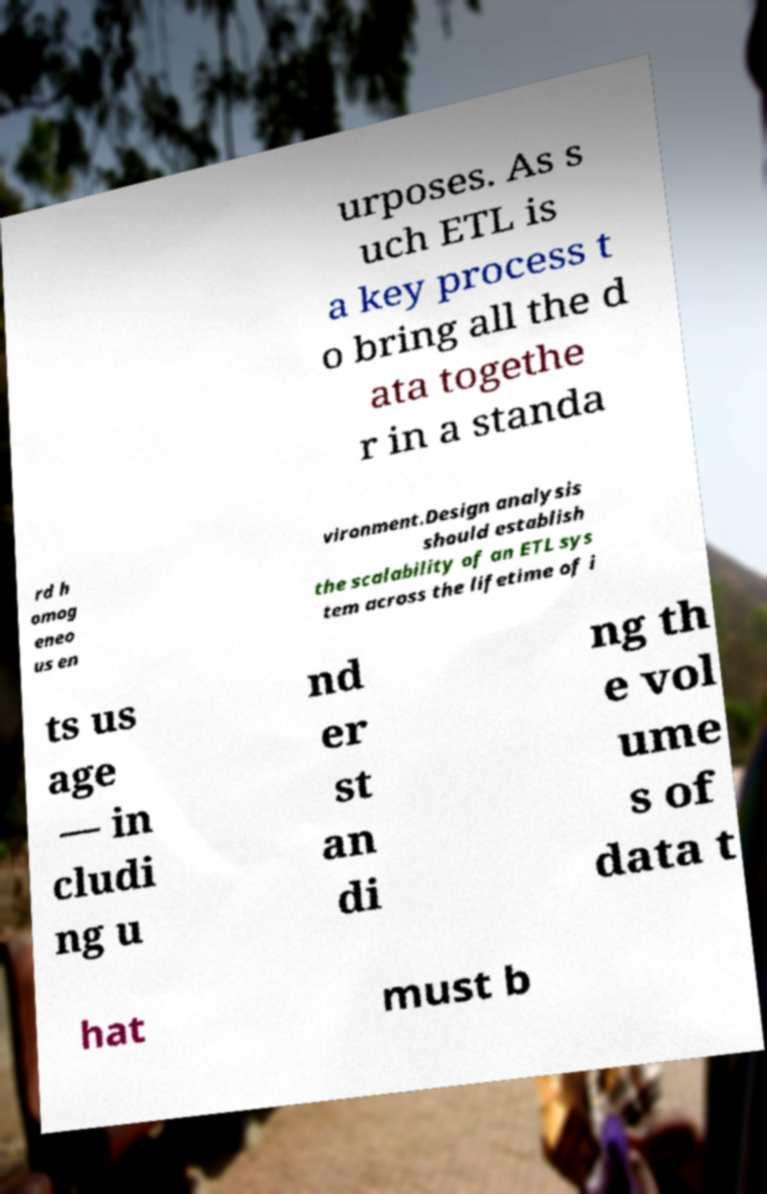For documentation purposes, I need the text within this image transcribed. Could you provide that? urposes. As s uch ETL is a key process t o bring all the d ata togethe r in a standa rd h omog eneo us en vironment.Design analysis should establish the scalability of an ETL sys tem across the lifetime of i ts us age — in cludi ng u nd er st an di ng th e vol ume s of data t hat must b 